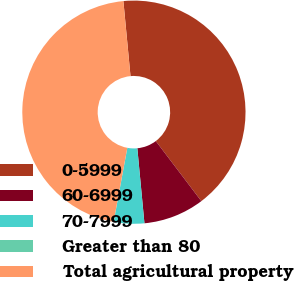Convert chart to OTSL. <chart><loc_0><loc_0><loc_500><loc_500><pie_chart><fcel>0-5999<fcel>60-6999<fcel>70-7999<fcel>Greater than 80<fcel>Total agricultural property<nl><fcel>41.18%<fcel>8.82%<fcel>4.41%<fcel>0.01%<fcel>45.58%<nl></chart> 